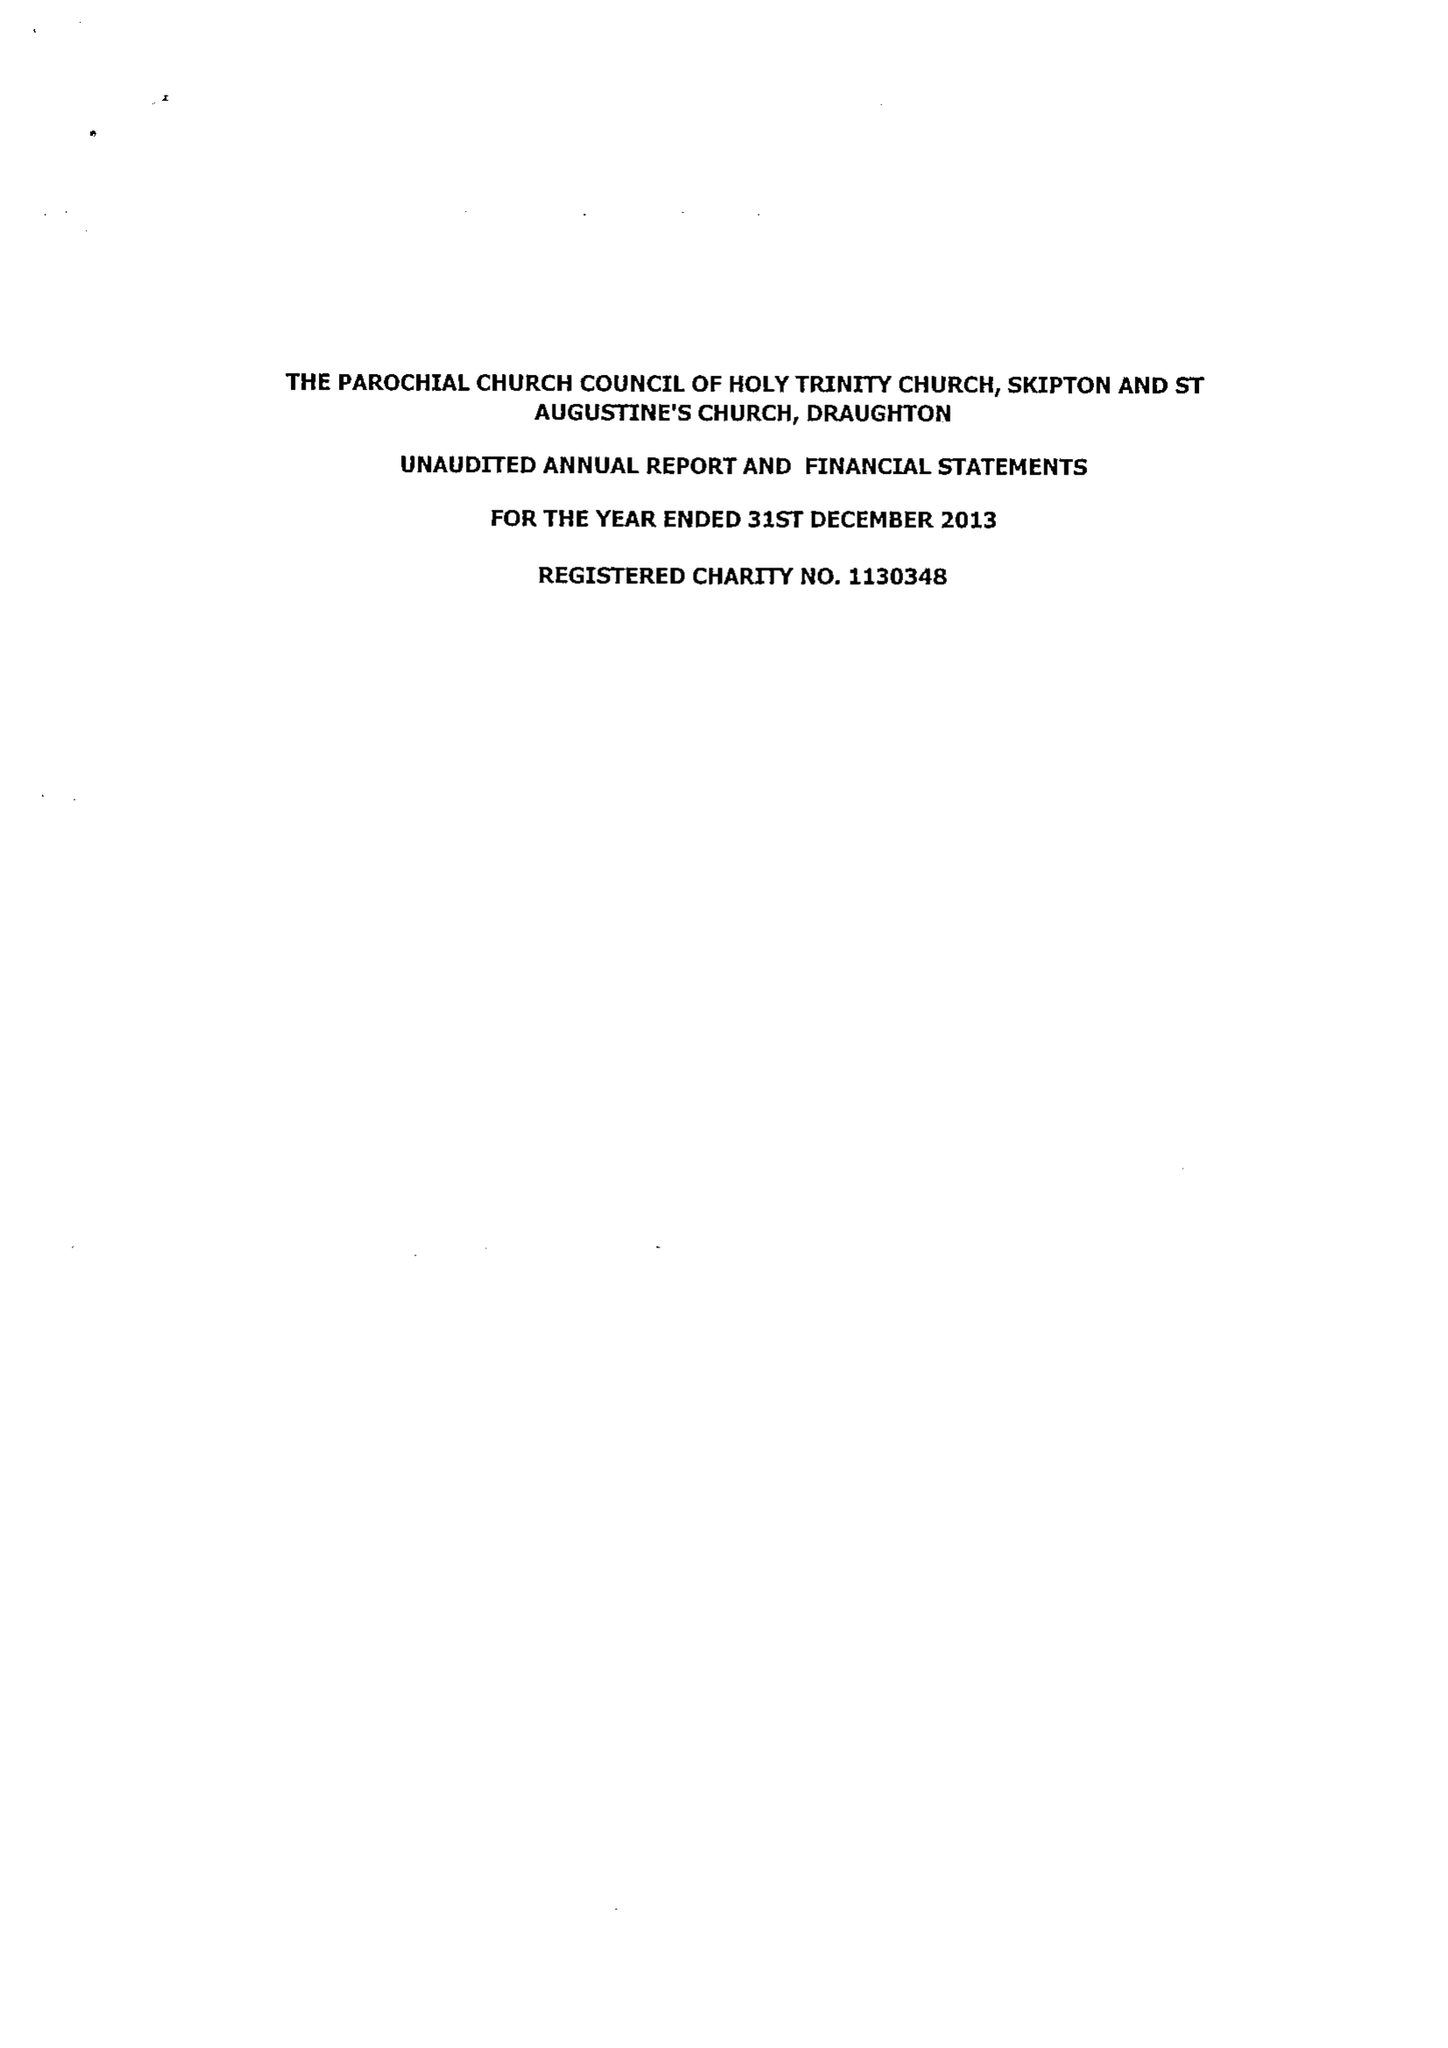What is the value for the income_annually_in_british_pounds?
Answer the question using a single word or phrase. 157305.00 